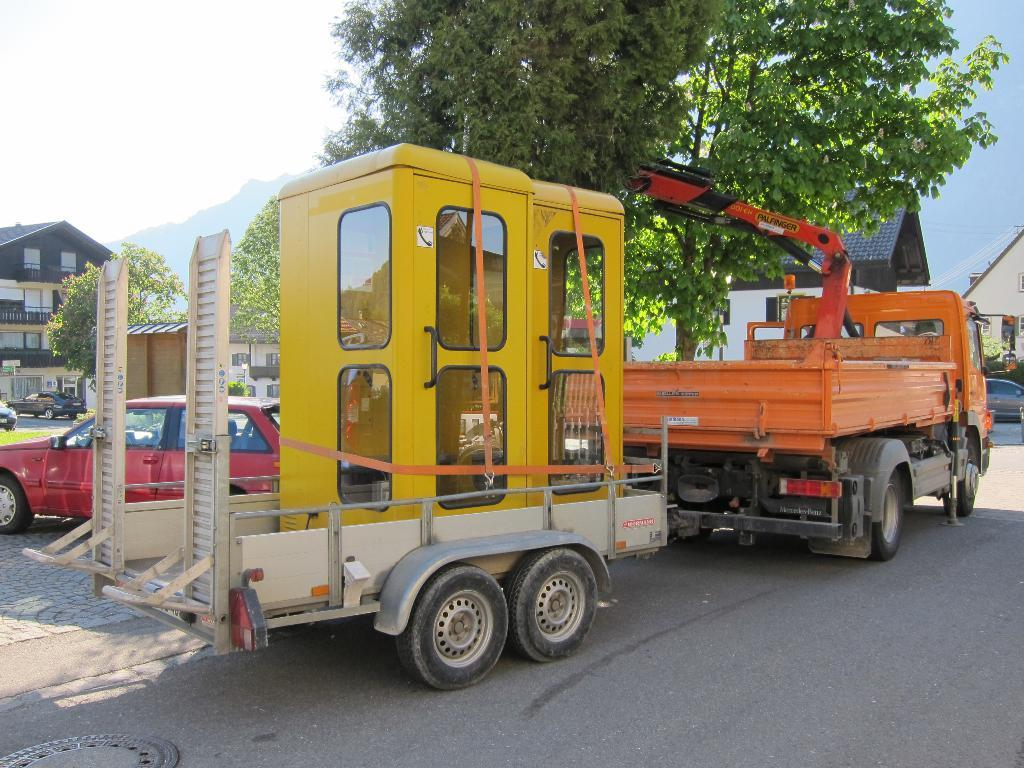What is happening on the road in the image? There are vehicles on the road in the image. What can be seen in the background of the image? There are trees, buildings, and a hill visible in the background of the image. Where is the sky visible in the image? The sky is visible at the top left of the image. How many cats are sitting on the hill in the image? There are no cats present in the image; it features vehicles on the road and a hill in the background. What type of wound can be seen on the hill in the image? There is no wound present in the image; it features a hill in the background without any visible injuries. 